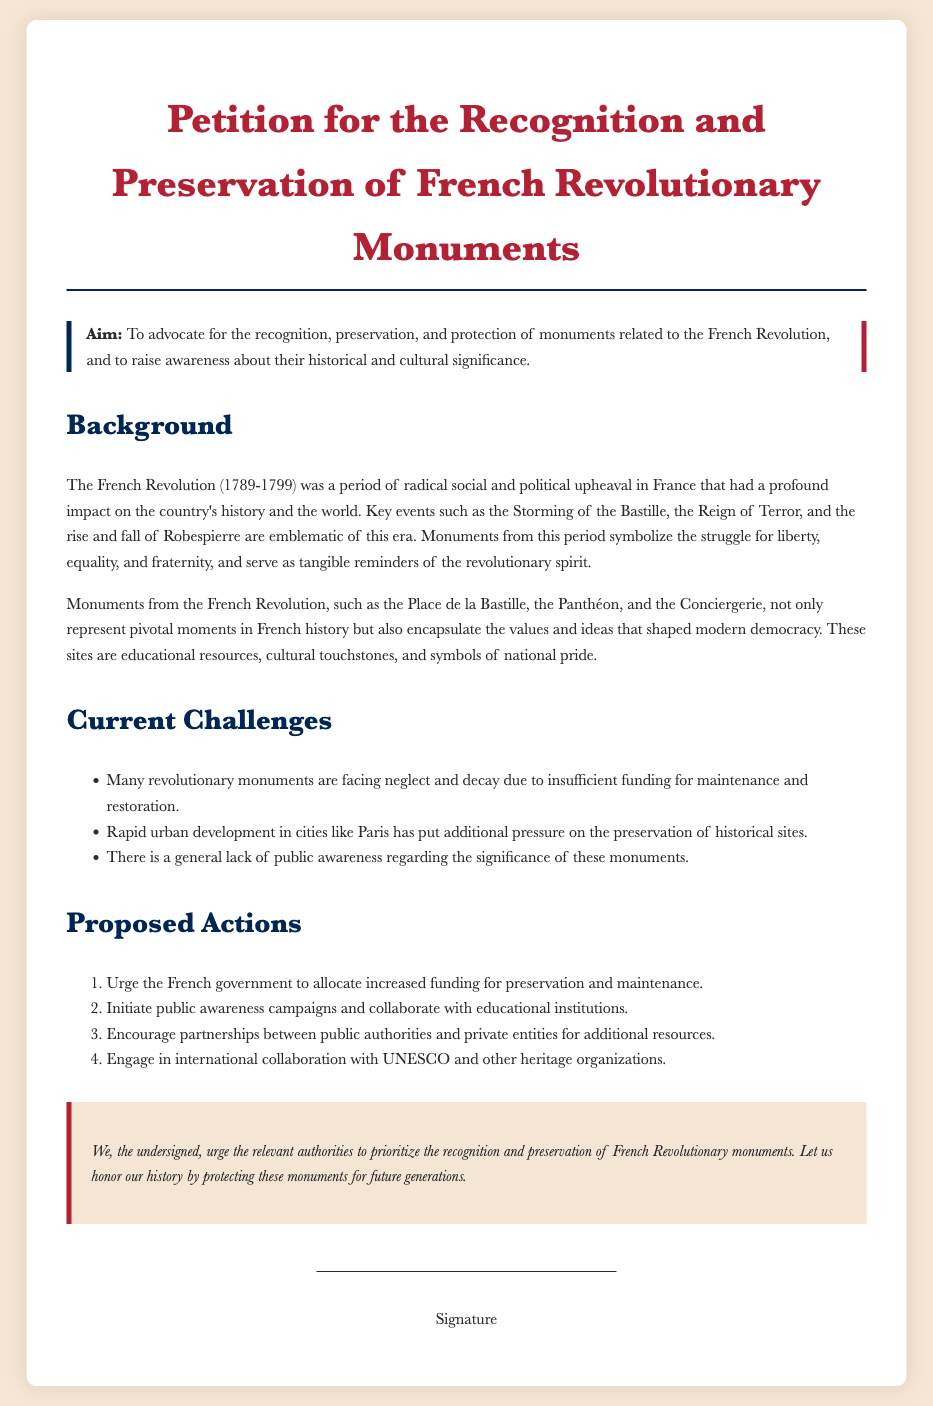What is the title of the petition? The title of the petition is presented prominently at the top of the document.
Answer: Petition for the Recognition and Preservation of French Revolutionary Monuments What are the key values symbolized by the monuments? The document mentions the values that these monuments represent, reflecting the ideals of the revolution.
Answer: Liberty, equality, and fraternity Which notable site is mentioned as a revolutionary monument? The document lists specific monuments, indicating their significance in French history.
Answer: Place de la Bastille What is one of the current challenges faced by revolutionary monuments? The document outlines issues related to the preservation of these monuments, including financial difficulties.
Answer: Neglect and decay Who should be urged to allocate increased funding? The petition emphasizes a specific authority that should take action towards preservation efforts.
Answer: French government How many proposed actions are outlined in the document? The document lists a certain number of actions intended to address the issues facing revolutionary monuments.
Answer: Four What is the purpose of the public awareness campaigns? The document describes the intention behind initiating campaigns concerning revolutionary monuments.
Answer: Raise awareness What organization is mentioned for international collaboration? The petition suggests collaboration with a specific heritage organization to enhance preservation efforts.
Answer: UNESCO 